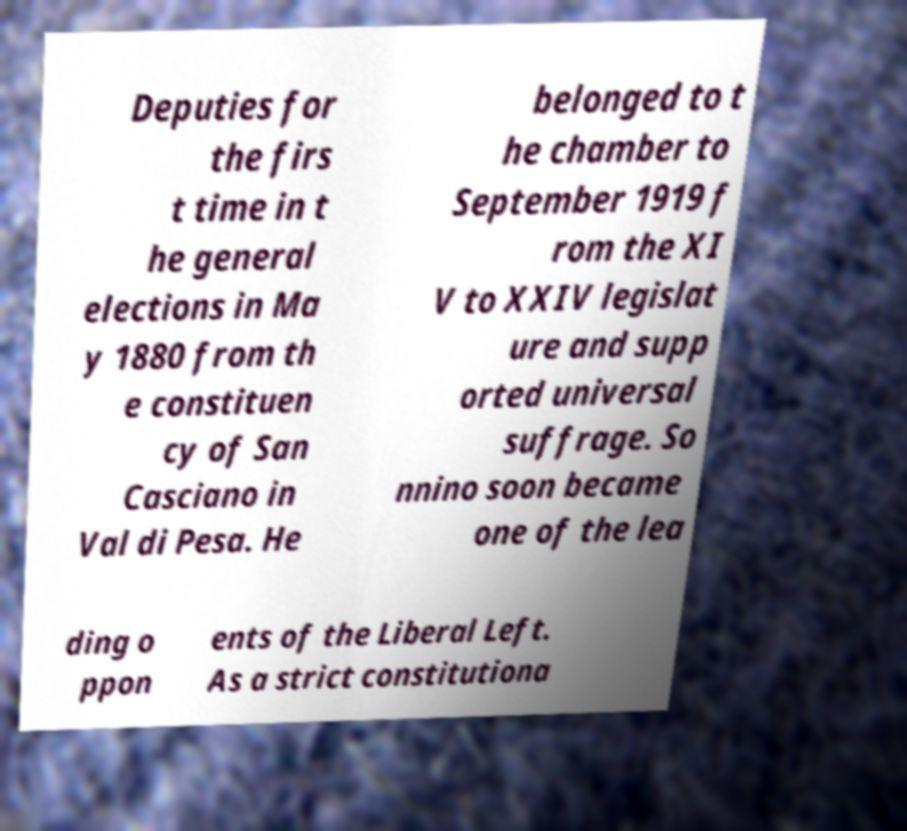Can you accurately transcribe the text from the provided image for me? Deputies for the firs t time in t he general elections in Ma y 1880 from th e constituen cy of San Casciano in Val di Pesa. He belonged to t he chamber to September 1919 f rom the XI V to XXIV legislat ure and supp orted universal suffrage. So nnino soon became one of the lea ding o ppon ents of the Liberal Left. As a strict constitutiona 